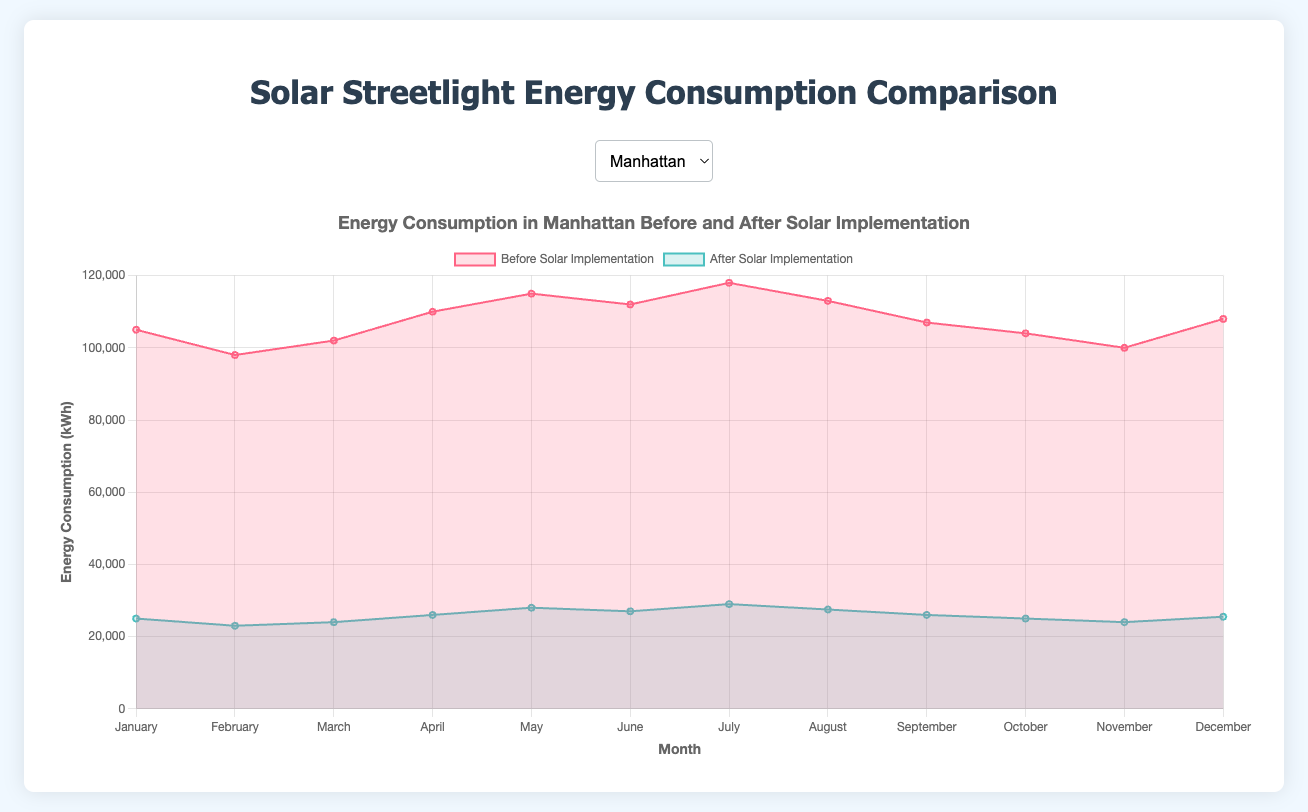How much did energy consumption decrease in Manhattan from January before implementation to January after implementation? To find the decrease, subtract the energy consumption in January after implementation from the energy consumption in January before implementation: 105,000 kWh (before) - 25,000 kWh (after) = 80,000 kWh
Answer: 80,000 kWh What month had the highest energy consumption in Brooklyn before solar implementation? By reviewing the chart for Brooklyn, we can see the data points for each month. The highest energy consumption before implementation is in July, with 98,000 kWh
Answer: July What's the difference in energy consumption for Queens between June before implementation and June after implementation? Subtract the energy consumption in June after implementation from the energy consumption in June before implementation: 99,000 kWh (before) - 22,500 kWh (after) = 76,500 kWh
Answer: 76,500 kWh Which borough had the lowest energy consumption in February after the implementation of solar panels? By examining the data for February after implementation for each borough, The Bronx has the lowest energy consumption with 14,500 kWh
Answer: The Bronx What's the average monthly energy consumption in The Bronx before implementing solar panels? Sum each month's energy consumption before implementation in The Bronx and divide by 12: (71,000 + 69,000 + 70,000 + 74,000 + 76,000 + 73,000 + 78,000 + 75,000 + 71,000 + 69,000 + 68,000 + 70,000) / 12 = 73,250 kWh
Answer: 73,250 kWh Between before and after implementation, which month in Queens shows the smallest change in energy consumption? Calculate the difference for each month in Queens and find the smallest change; May has a difference of 102,000 kWh (before) - 23,000 kWh (after) = 79,000 kWh, which is the smallest change compared to other months
Answer: May What is the percentage reduction in energy consumption in Brooklyn from before to after implementation in July? Calculate the percentage reduction: ((98,000 - 23,000) / 98,000) * 100 = 76.53%
Answer: 76.53% During December, which borough showed the highest reduction in energy consumption after implementing solar panels? The reductions in December are: Manhattan – 108,000 kWh to 25,500 kWh (82,500 kWh), Brooklyn – 91,000 kWh to 20,500 kWh (70,500 kWh), Queens – 97,000 kWh to 22,000 kWh (75,000 kWh), and The Bronx – 70,000 kWh to 16,000 kWh (54,000 kWh). Manhattan shows the highest reduction with 82,500 kWh
Answer: Manhattan What is the total energy consumption in Brooklyn after implementing solar panels over the year? Sum each month's energy consumption after implementation in Brooklyn: 20,000 + 19,000 + 19,500 + 20,500 + 22,000 + 21,000 + 23,000 + 22,000 + 21,000 + 20,000 + 19,500 + 20,500 = 248,000 kWh
Answer: 248,000 kWh Which borough has the greatest variability in energy consumption before implementation, as shown in the chart? The variability can be determined by observing the range of energy consumption values (difference between highest and lowest points). Manhattan shows the greatest variability (highest: 118,000 kWh, lowest: 98,000 kWh, range: 20,000 kWh)
Answer: Manhattan 